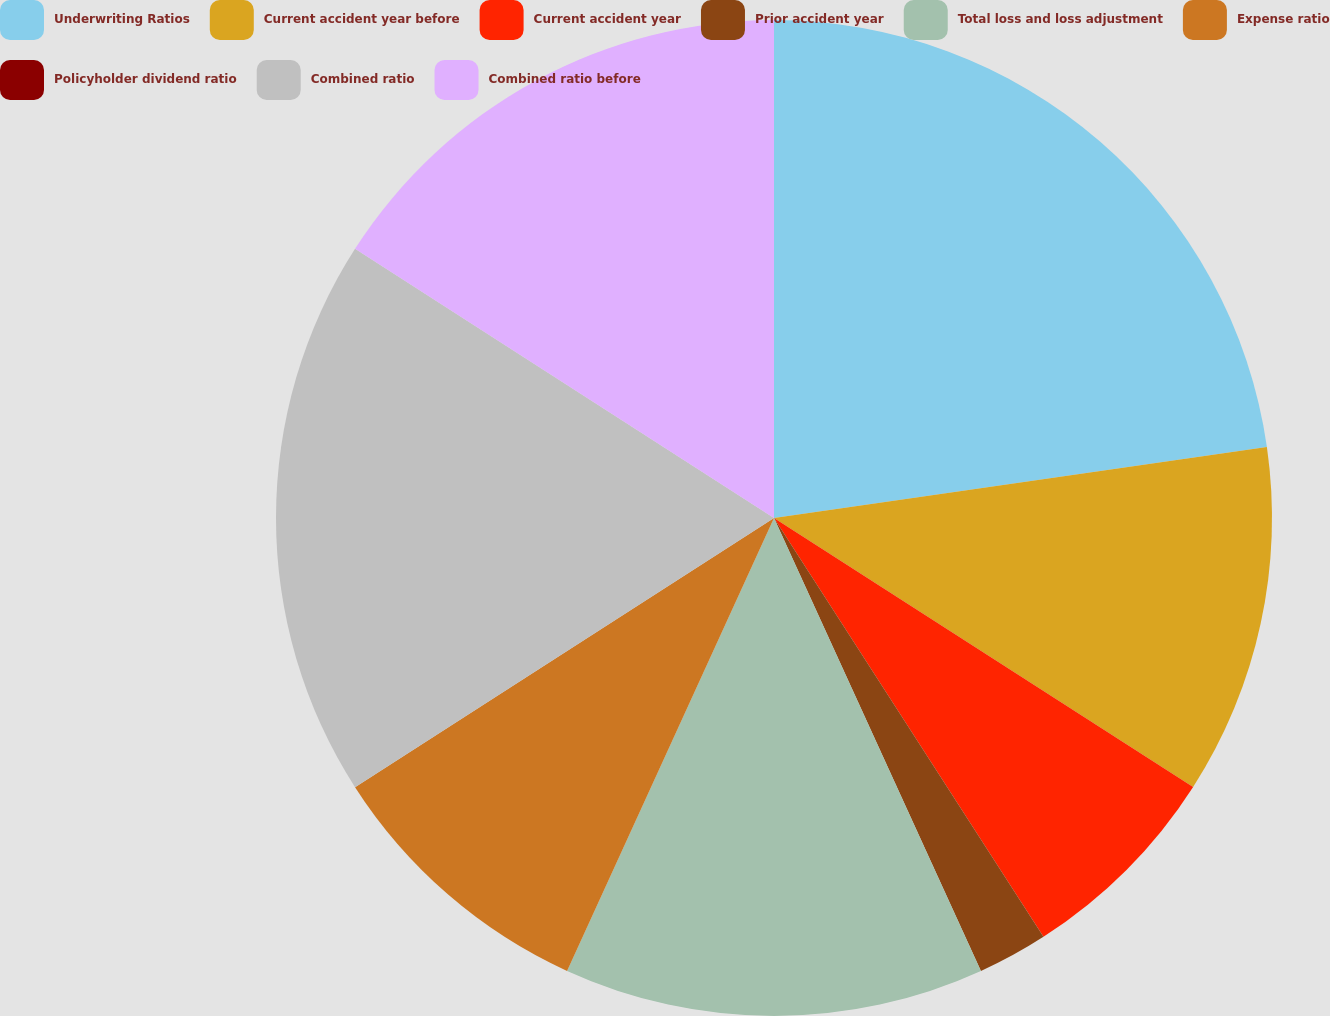Convert chart to OTSL. <chart><loc_0><loc_0><loc_500><loc_500><pie_chart><fcel>Underwriting Ratios<fcel>Current accident year before<fcel>Current accident year<fcel>Prior accident year<fcel>Total loss and loss adjustment<fcel>Expense ratio<fcel>Policyholder dividend ratio<fcel>Combined ratio<fcel>Combined ratio before<nl><fcel>22.72%<fcel>11.36%<fcel>6.82%<fcel>2.28%<fcel>13.64%<fcel>9.09%<fcel>0.0%<fcel>18.18%<fcel>15.91%<nl></chart> 